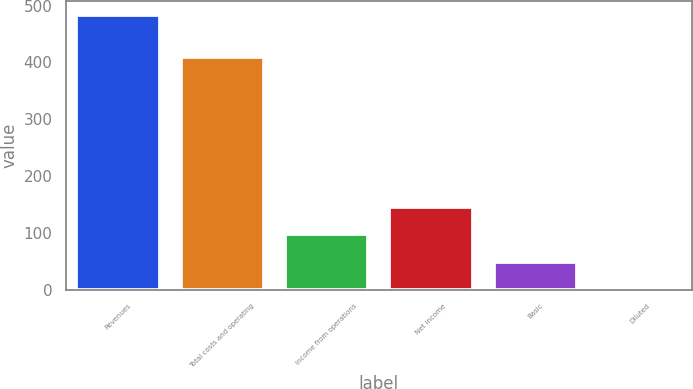<chart> <loc_0><loc_0><loc_500><loc_500><bar_chart><fcel>Revenues<fcel>Total costs and operating<fcel>Income from operations<fcel>Net income<fcel>Basic<fcel>Diluted<nl><fcel>484<fcel>409<fcel>97.09<fcel>145.45<fcel>48.73<fcel>0.37<nl></chart> 